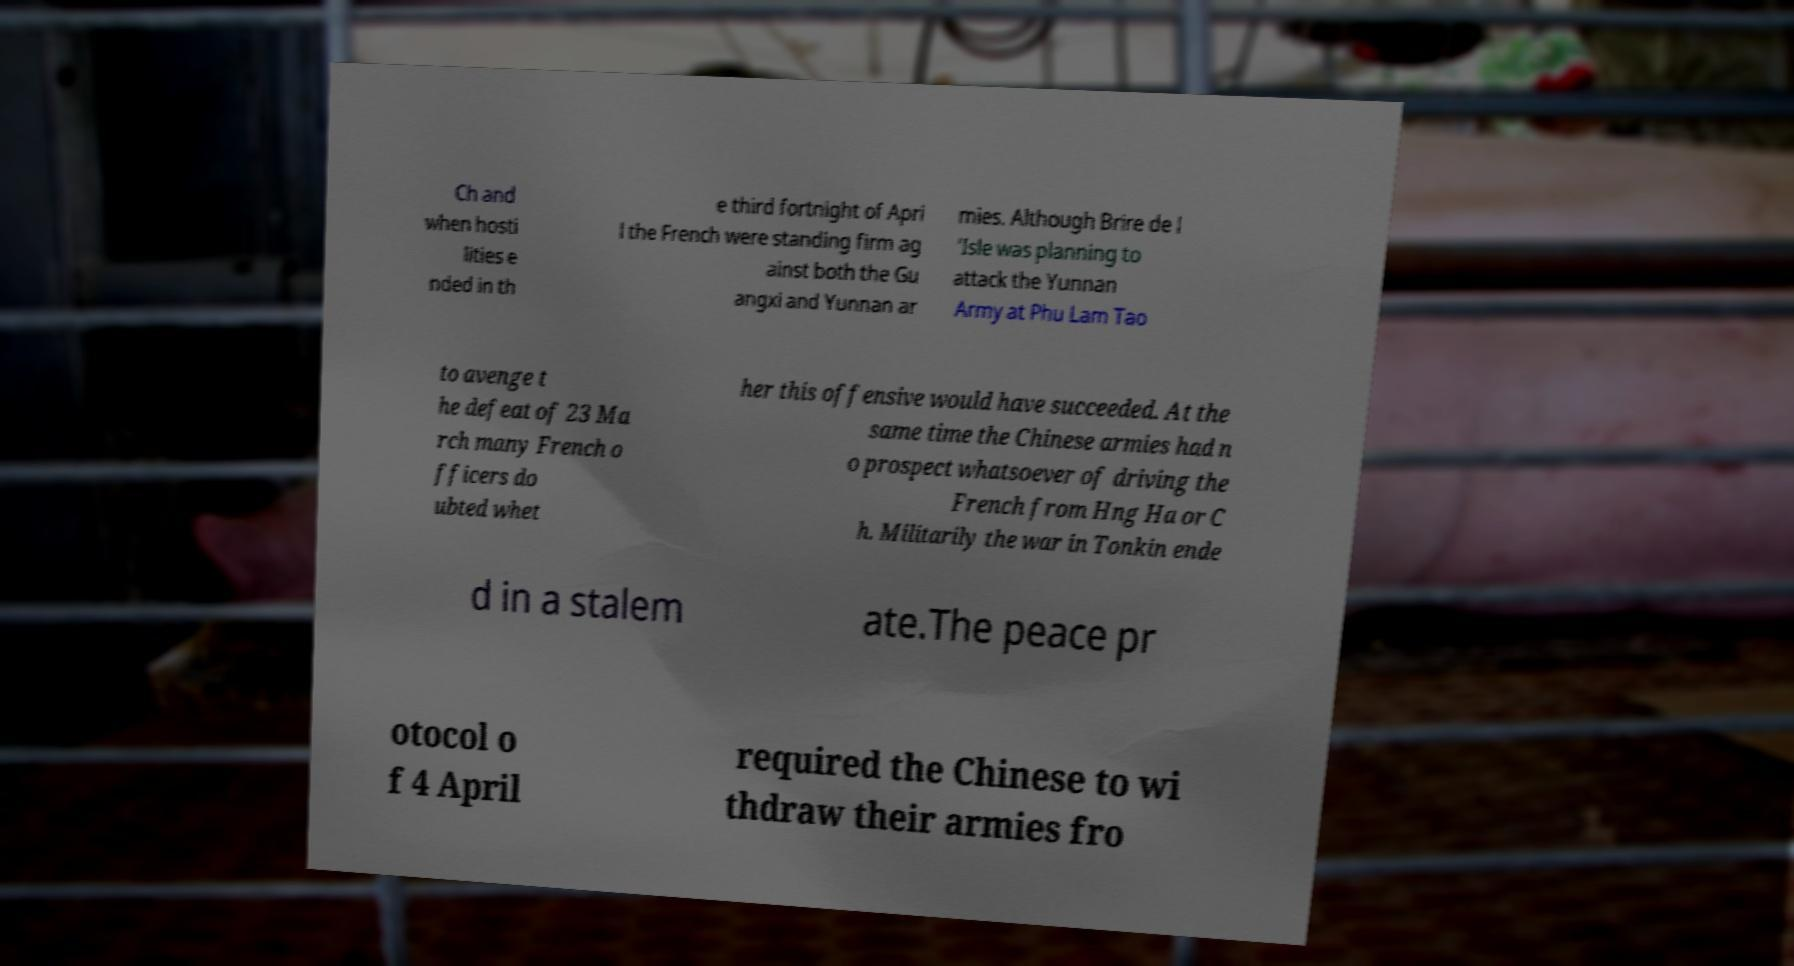Please read and relay the text visible in this image. What does it say? Ch and when hosti lities e nded in th e third fortnight of Apri l the French were standing firm ag ainst both the Gu angxi and Yunnan ar mies. Although Brire de l 'Isle was planning to attack the Yunnan Army at Phu Lam Tao to avenge t he defeat of 23 Ma rch many French o fficers do ubted whet her this offensive would have succeeded. At the same time the Chinese armies had n o prospect whatsoever of driving the French from Hng Ha or C h. Militarily the war in Tonkin ende d in a stalem ate.The peace pr otocol o f 4 April required the Chinese to wi thdraw their armies fro 